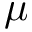Convert formula to latex. <formula><loc_0><loc_0><loc_500><loc_500>\mu</formula> 